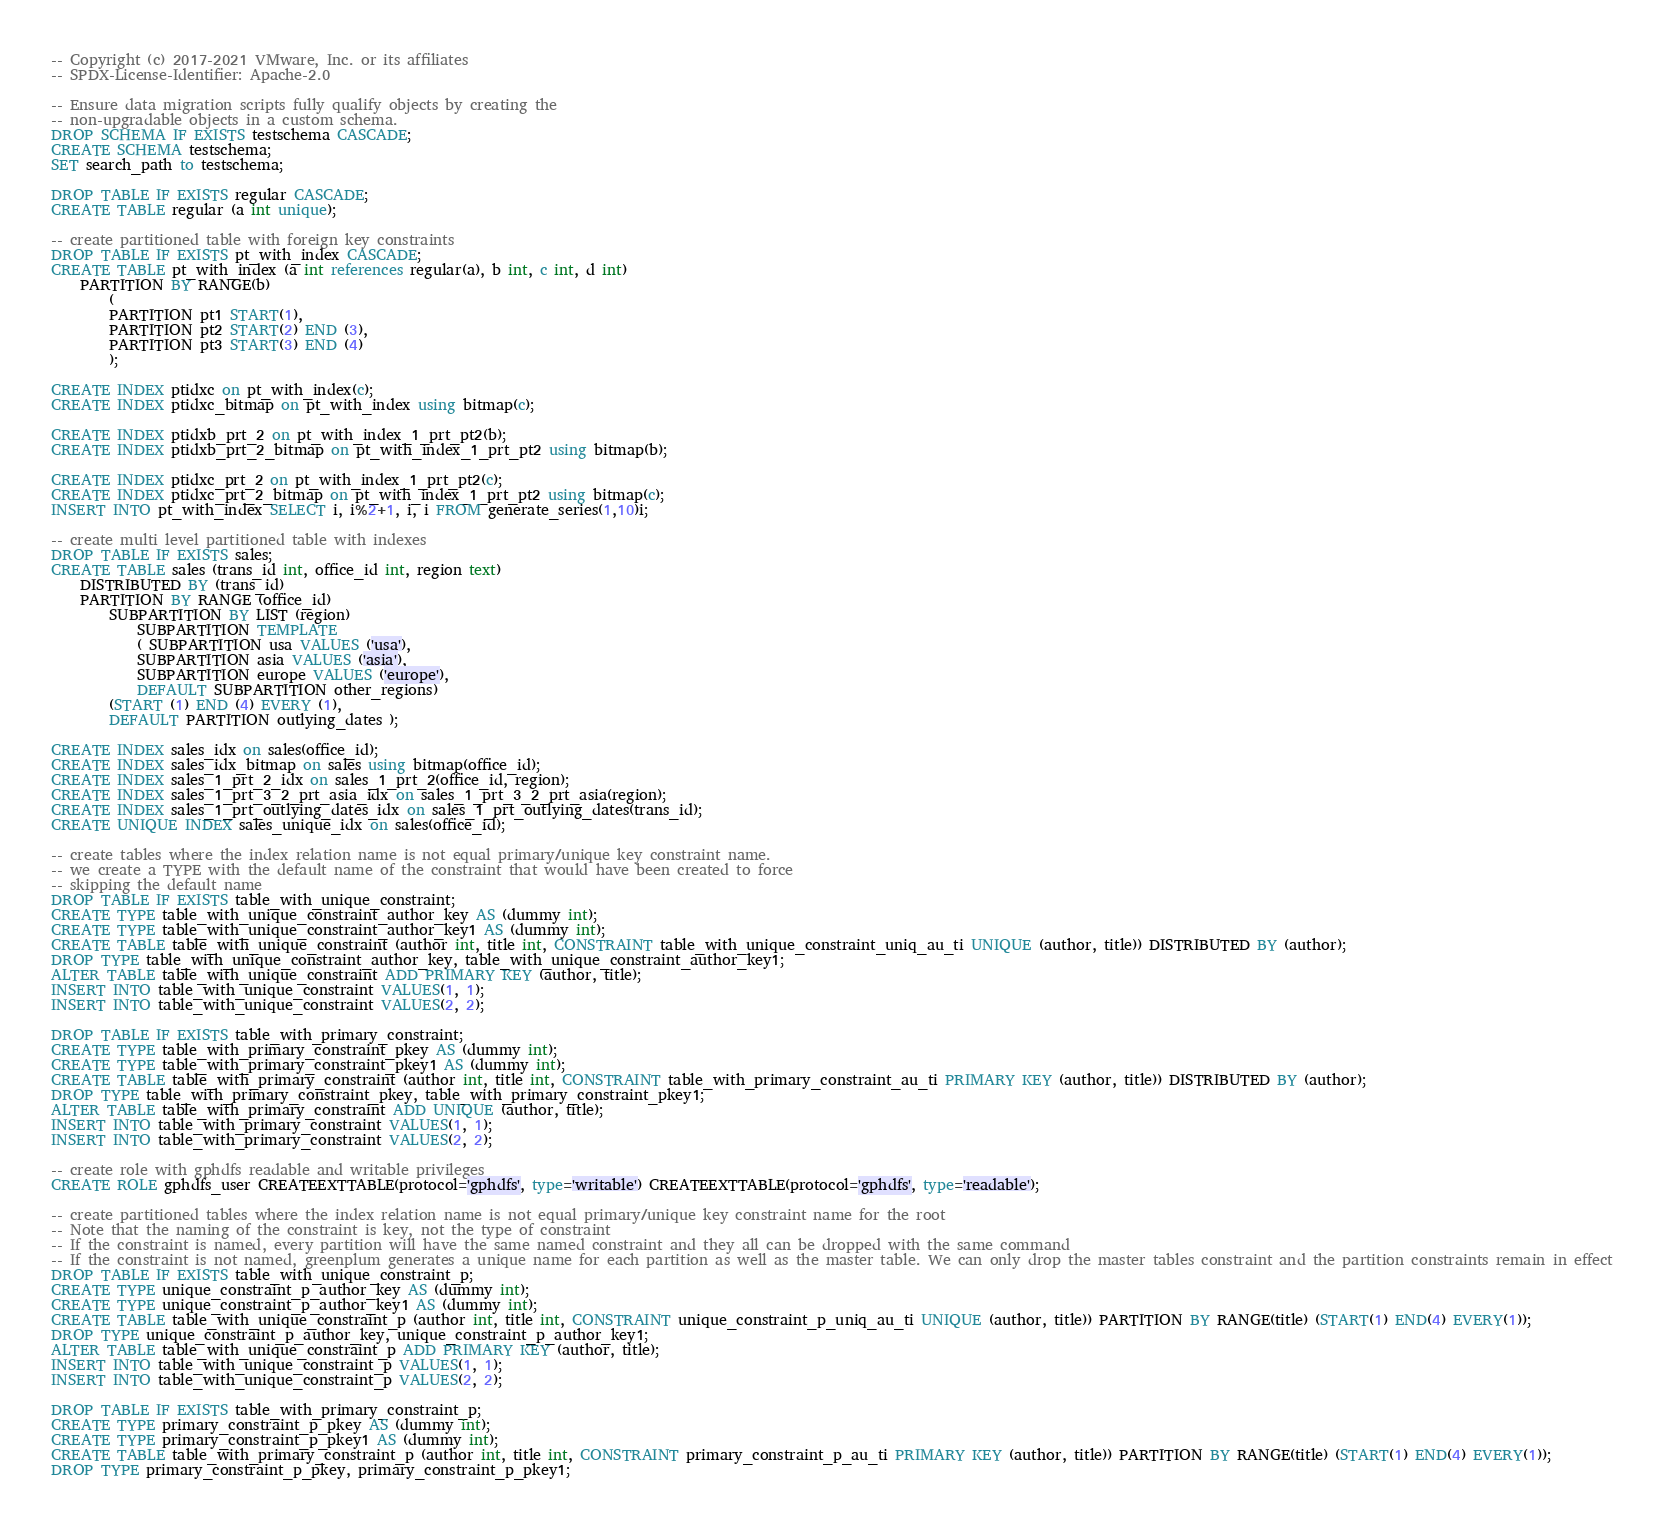Convert code to text. <code><loc_0><loc_0><loc_500><loc_500><_SQL_>-- Copyright (c) 2017-2021 VMware, Inc. or its affiliates
-- SPDX-License-Identifier: Apache-2.0

-- Ensure data migration scripts fully qualify objects by creating the
-- non-upgradable objects in a custom schema.
DROP SCHEMA IF EXISTS testschema CASCADE;
CREATE SCHEMA testschema;
SET search_path to testschema;

DROP TABLE IF EXISTS regular CASCADE;
CREATE TABLE regular (a int unique);

-- create partitioned table with foreign key constraints
DROP TABLE IF EXISTS pt_with_index CASCADE;
CREATE TABLE pt_with_index (a int references regular(a), b int, c int, d int)
    PARTITION BY RANGE(b)
        (
        PARTITION pt1 START(1),
        PARTITION pt2 START(2) END (3),
        PARTITION pt3 START(3) END (4)
        );

CREATE INDEX ptidxc on pt_with_index(c);
CREATE INDEX ptidxc_bitmap on pt_with_index using bitmap(c);

CREATE INDEX ptidxb_prt_2 on pt_with_index_1_prt_pt2(b);
CREATE INDEX ptidxb_prt_2_bitmap on pt_with_index_1_prt_pt2 using bitmap(b);

CREATE INDEX ptidxc_prt_2 on pt_with_index_1_prt_pt2(c);
CREATE INDEX ptidxc_prt_2_bitmap on pt_with_index_1_prt_pt2 using bitmap(c);
INSERT INTO pt_with_index SELECT i, i%2+1, i, i FROM generate_series(1,10)i;

-- create multi level partitioned table with indexes
DROP TABLE IF EXISTS sales;
CREATE TABLE sales (trans_id int, office_id int, region text)
    DISTRIBUTED BY (trans_id)
    PARTITION BY RANGE (office_id)
        SUBPARTITION BY LIST (region)
            SUBPARTITION TEMPLATE
            ( SUBPARTITION usa VALUES ('usa'),
            SUBPARTITION asia VALUES ('asia'),
            SUBPARTITION europe VALUES ('europe'),
            DEFAULT SUBPARTITION other_regions)
        (START (1) END (4) EVERY (1),
        DEFAULT PARTITION outlying_dates );

CREATE INDEX sales_idx on sales(office_id);
CREATE INDEX sales_idx_bitmap on sales using bitmap(office_id);
CREATE INDEX sales_1_prt_2_idx on sales_1_prt_2(office_id, region);
CREATE INDEX sales_1_prt_3_2_prt_asia_idx on sales_1_prt_3_2_prt_asia(region);
CREATE INDEX sales_1_prt_outlying_dates_idx on sales_1_prt_outlying_dates(trans_id);
CREATE UNIQUE INDEX sales_unique_idx on sales(office_id);

-- create tables where the index relation name is not equal primary/unique key constraint name.
-- we create a TYPE with the default name of the constraint that would have been created to force
-- skipping the default name
DROP TABLE IF EXISTS table_with_unique_constraint;
CREATE TYPE table_with_unique_constraint_author_key AS (dummy int);
CREATE TYPE table_with_unique_constraint_author_key1 AS (dummy int);
CREATE TABLE table_with_unique_constraint (author int, title int, CONSTRAINT table_with_unique_constraint_uniq_au_ti UNIQUE (author, title)) DISTRIBUTED BY (author);
DROP TYPE table_with_unique_constraint_author_key, table_with_unique_constraint_author_key1;
ALTER TABLE table_with_unique_constraint ADD PRIMARY KEY (author, title);
INSERT INTO table_with_unique_constraint VALUES(1, 1);
INSERT INTO table_with_unique_constraint VALUES(2, 2);

DROP TABLE IF EXISTS table_with_primary_constraint;
CREATE TYPE table_with_primary_constraint_pkey AS (dummy int);
CREATE TYPE table_with_primary_constraint_pkey1 AS (dummy int);
CREATE TABLE table_with_primary_constraint (author int, title int, CONSTRAINT table_with_primary_constraint_au_ti PRIMARY KEY (author, title)) DISTRIBUTED BY (author);
DROP TYPE table_with_primary_constraint_pkey, table_with_primary_constraint_pkey1;
ALTER TABLE table_with_primary_constraint ADD UNIQUE (author, title);
INSERT INTO table_with_primary_constraint VALUES(1, 1);
INSERT INTO table_with_primary_constraint VALUES(2, 2);

-- create role with gphdfs readable and writable privileges
CREATE ROLE gphdfs_user CREATEEXTTABLE(protocol='gphdfs', type='writable') CREATEEXTTABLE(protocol='gphdfs', type='readable');

-- create partitioned tables where the index relation name is not equal primary/unique key constraint name for the root
-- Note that the naming of the constraint is key, not the type of constraint
-- If the constraint is named, every partition will have the same named constraint and they all can be dropped with the same command
-- If the constraint is not named, greenplum generates a unique name for each partition as well as the master table. We can only drop the master tables constraint and the partition constraints remain in effect
DROP TABLE IF EXISTS table_with_unique_constraint_p;
CREATE TYPE unique_constraint_p_author_key AS (dummy int);
CREATE TYPE unique_constraint_p_author_key1 AS (dummy int);
CREATE TABLE table_with_unique_constraint_p (author int, title int, CONSTRAINT unique_constraint_p_uniq_au_ti UNIQUE (author, title)) PARTITION BY RANGE(title) (START(1) END(4) EVERY(1));
DROP TYPE unique_constraint_p_author_key, unique_constraint_p_author_key1;
ALTER TABLE table_with_unique_constraint_p ADD PRIMARY KEY (author, title);
INSERT INTO table_with_unique_constraint_p VALUES(1, 1);
INSERT INTO table_with_unique_constraint_p VALUES(2, 2);

DROP TABLE IF EXISTS table_with_primary_constraint_p;
CREATE TYPE primary_constraint_p_pkey AS (dummy int);
CREATE TYPE primary_constraint_p_pkey1 AS (dummy int);
CREATE TABLE table_with_primary_constraint_p (author int, title int, CONSTRAINT primary_constraint_p_au_ti PRIMARY KEY (author, title)) PARTITION BY RANGE(title) (START(1) END(4) EVERY(1));
DROP TYPE primary_constraint_p_pkey, primary_constraint_p_pkey1;</code> 